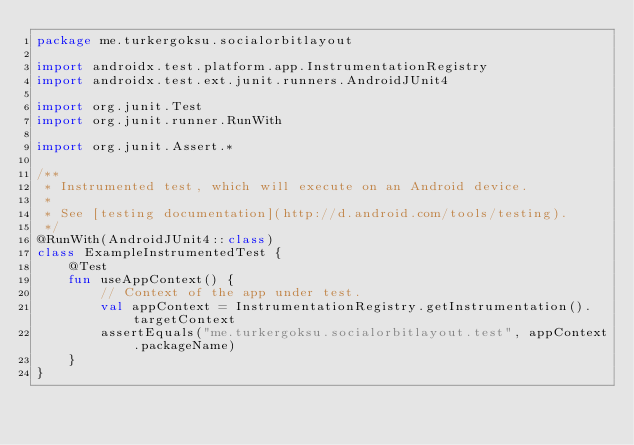<code> <loc_0><loc_0><loc_500><loc_500><_Kotlin_>package me.turkergoksu.socialorbitlayout

import androidx.test.platform.app.InstrumentationRegistry
import androidx.test.ext.junit.runners.AndroidJUnit4

import org.junit.Test
import org.junit.runner.RunWith

import org.junit.Assert.*

/**
 * Instrumented test, which will execute on an Android device.
 *
 * See [testing documentation](http://d.android.com/tools/testing).
 */
@RunWith(AndroidJUnit4::class)
class ExampleInstrumentedTest {
    @Test
    fun useAppContext() {
        // Context of the app under test.
        val appContext = InstrumentationRegistry.getInstrumentation().targetContext
        assertEquals("me.turkergoksu.socialorbitlayout.test", appContext.packageName)
    }
}</code> 